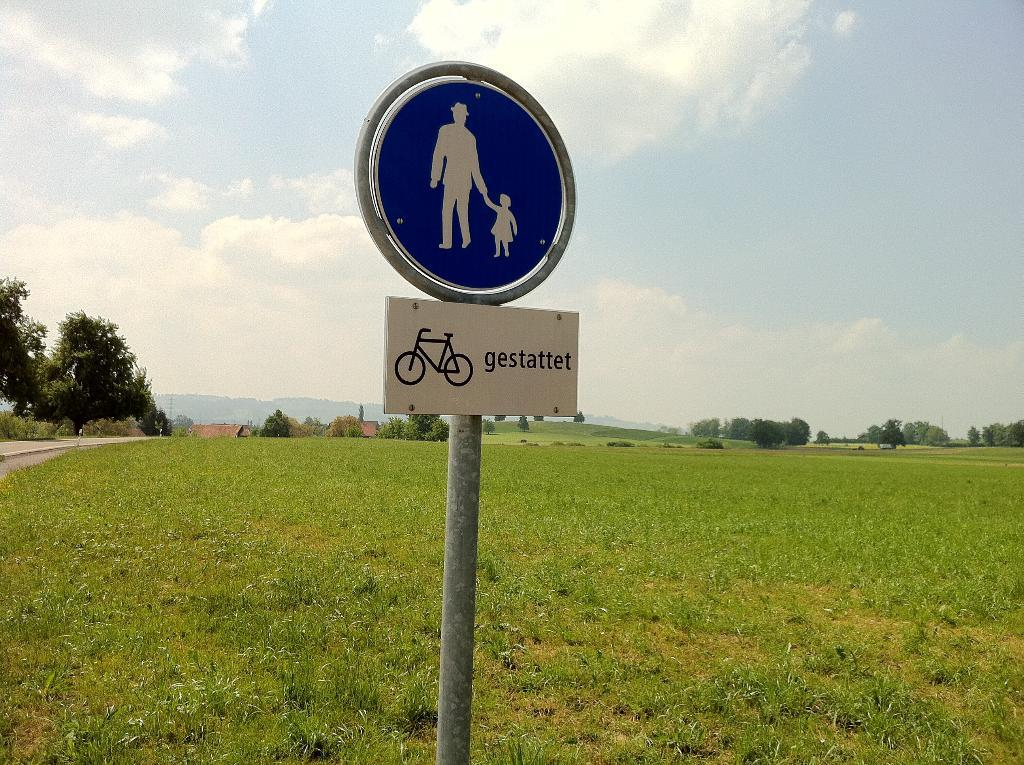What is the main object in the image? There is a sign board in the image. What can be seen on the left side of the image? There are trees on the left side of the image. What is visible at the top of the image? The sky is visible at the top of the image. Can you see the cook preparing a meal in the image? There is no cook or meal preparation visible in the image. Is there a deer present in the image? There is no deer present in the image. 